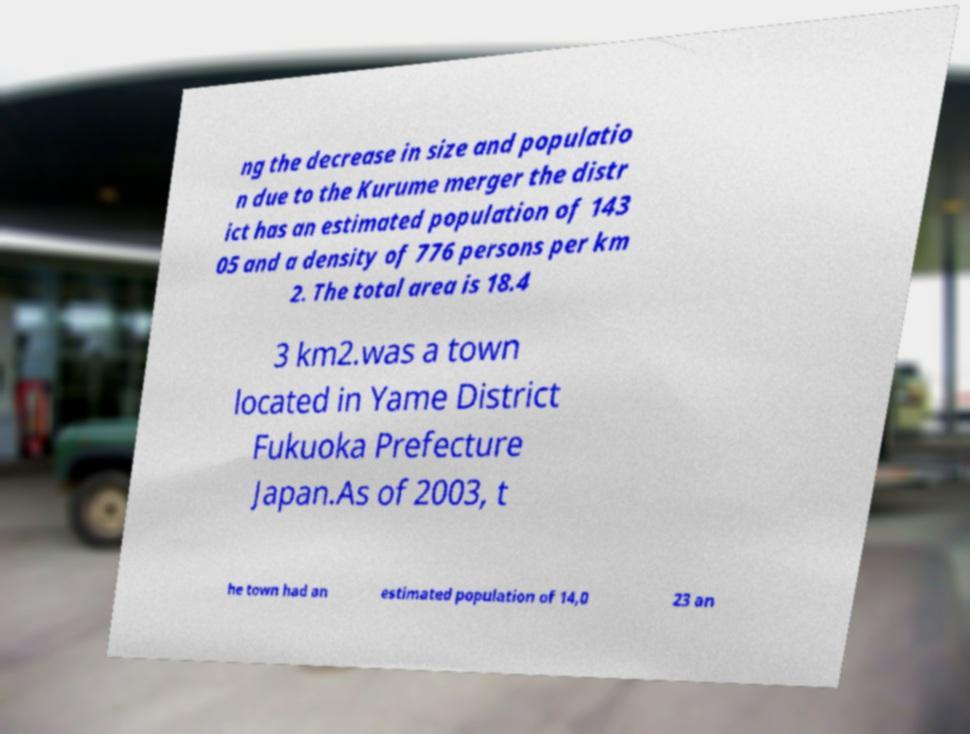For documentation purposes, I need the text within this image transcribed. Could you provide that? ng the decrease in size and populatio n due to the Kurume merger the distr ict has an estimated population of 143 05 and a density of 776 persons per km 2. The total area is 18.4 3 km2.was a town located in Yame District Fukuoka Prefecture Japan.As of 2003, t he town had an estimated population of 14,0 23 an 